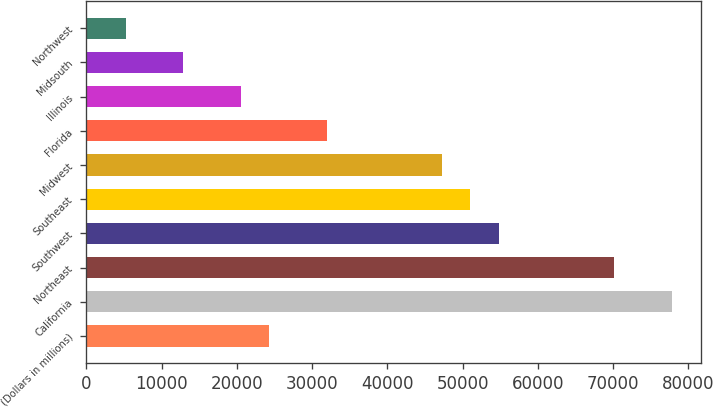Convert chart. <chart><loc_0><loc_0><loc_500><loc_500><bar_chart><fcel>(Dollars in millions)<fcel>California<fcel>Northeast<fcel>Southwest<fcel>Southeast<fcel>Midwest<fcel>Florida<fcel>Illinois<fcel>Midsouth<fcel>Northwest<nl><fcel>24327.6<fcel>77767<fcel>70132.8<fcel>54864.4<fcel>51047.3<fcel>47230.2<fcel>31961.8<fcel>20510.5<fcel>12876.3<fcel>5242.1<nl></chart> 